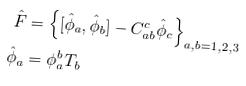<formula> <loc_0><loc_0><loc_500><loc_500>\hat { F } & = \left \{ [ \hat { \phi } _ { a } , \hat { \phi } _ { b } ] - C _ { a b } ^ { c } \hat { \phi } _ { c } \right \} _ { a , b = 1 , 2 , 3 } \\ \hat { \phi } _ { a } & = \phi _ { a } ^ { b } T _ { b }</formula> 